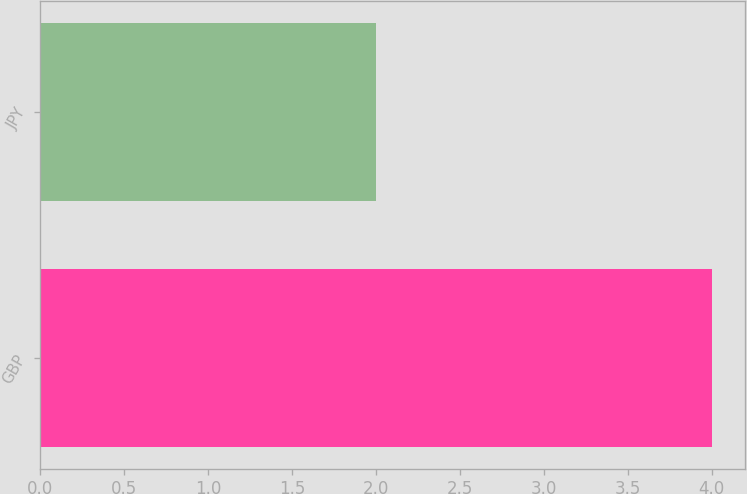Convert chart to OTSL. <chart><loc_0><loc_0><loc_500><loc_500><bar_chart><fcel>GBP<fcel>JPY<nl><fcel>4<fcel>2<nl></chart> 